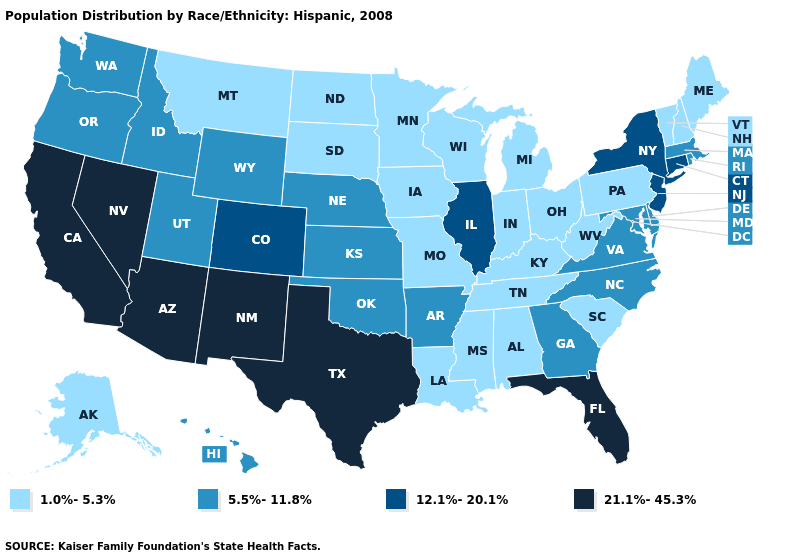Name the states that have a value in the range 21.1%-45.3%?
Keep it brief. Arizona, California, Florida, Nevada, New Mexico, Texas. Name the states that have a value in the range 5.5%-11.8%?
Give a very brief answer. Arkansas, Delaware, Georgia, Hawaii, Idaho, Kansas, Maryland, Massachusetts, Nebraska, North Carolina, Oklahoma, Oregon, Rhode Island, Utah, Virginia, Washington, Wyoming. What is the value of Hawaii?
Write a very short answer. 5.5%-11.8%. Does Idaho have a lower value than Connecticut?
Short answer required. Yes. What is the lowest value in the South?
Concise answer only. 1.0%-5.3%. What is the value of Louisiana?
Quick response, please. 1.0%-5.3%. Does the map have missing data?
Quick response, please. No. What is the highest value in states that border Oregon?
Give a very brief answer. 21.1%-45.3%. What is the value of Utah?
Answer briefly. 5.5%-11.8%. Does New York have the highest value in the Northeast?
Quick response, please. Yes. Does Mississippi have the lowest value in the USA?
Answer briefly. Yes. Is the legend a continuous bar?
Give a very brief answer. No. What is the highest value in the South ?
Be succinct. 21.1%-45.3%. Does the map have missing data?
Answer briefly. No. Name the states that have a value in the range 12.1%-20.1%?
Short answer required. Colorado, Connecticut, Illinois, New Jersey, New York. 